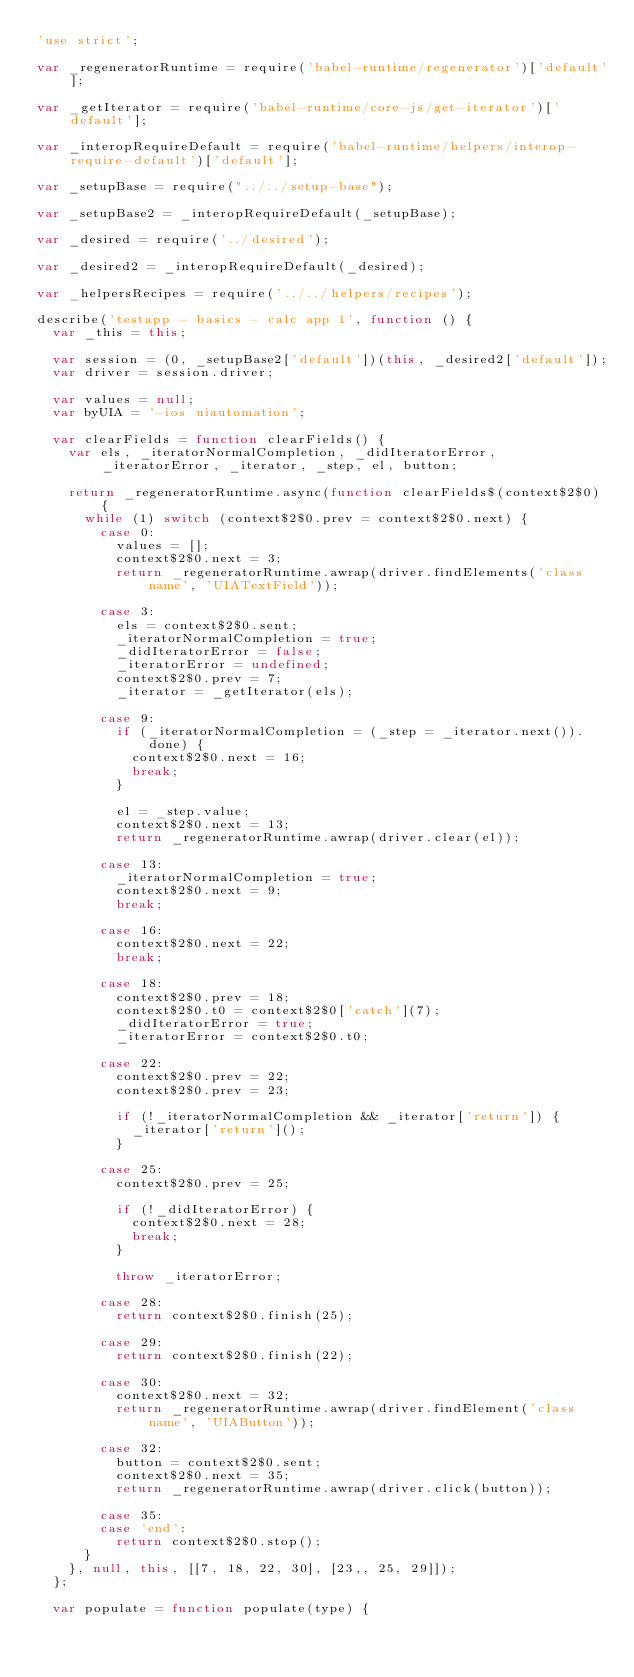Convert code to text. <code><loc_0><loc_0><loc_500><loc_500><_JavaScript_>'use strict';

var _regeneratorRuntime = require('babel-runtime/regenerator')['default'];

var _getIterator = require('babel-runtime/core-js/get-iterator')['default'];

var _interopRequireDefault = require('babel-runtime/helpers/interop-require-default')['default'];

var _setupBase = require("../../setup-base");

var _setupBase2 = _interopRequireDefault(_setupBase);

var _desired = require('../desired');

var _desired2 = _interopRequireDefault(_desired);

var _helpersRecipes = require('../../helpers/recipes');

describe('testapp - basics - calc app 1', function () {
  var _this = this;

  var session = (0, _setupBase2['default'])(this, _desired2['default']);
  var driver = session.driver;

  var values = null;
  var byUIA = '-ios uiautomation';

  var clearFields = function clearFields() {
    var els, _iteratorNormalCompletion, _didIteratorError, _iteratorError, _iterator, _step, el, button;

    return _regeneratorRuntime.async(function clearFields$(context$2$0) {
      while (1) switch (context$2$0.prev = context$2$0.next) {
        case 0:
          values = [];
          context$2$0.next = 3;
          return _regeneratorRuntime.awrap(driver.findElements('class name', 'UIATextField'));

        case 3:
          els = context$2$0.sent;
          _iteratorNormalCompletion = true;
          _didIteratorError = false;
          _iteratorError = undefined;
          context$2$0.prev = 7;
          _iterator = _getIterator(els);

        case 9:
          if (_iteratorNormalCompletion = (_step = _iterator.next()).done) {
            context$2$0.next = 16;
            break;
          }

          el = _step.value;
          context$2$0.next = 13;
          return _regeneratorRuntime.awrap(driver.clear(el));

        case 13:
          _iteratorNormalCompletion = true;
          context$2$0.next = 9;
          break;

        case 16:
          context$2$0.next = 22;
          break;

        case 18:
          context$2$0.prev = 18;
          context$2$0.t0 = context$2$0['catch'](7);
          _didIteratorError = true;
          _iteratorError = context$2$0.t0;

        case 22:
          context$2$0.prev = 22;
          context$2$0.prev = 23;

          if (!_iteratorNormalCompletion && _iterator['return']) {
            _iterator['return']();
          }

        case 25:
          context$2$0.prev = 25;

          if (!_didIteratorError) {
            context$2$0.next = 28;
            break;
          }

          throw _iteratorError;

        case 28:
          return context$2$0.finish(25);

        case 29:
          return context$2$0.finish(22);

        case 30:
          context$2$0.next = 32;
          return _regeneratorRuntime.awrap(driver.findElement('class name', 'UIAButton'));

        case 32:
          button = context$2$0.sent;
          context$2$0.next = 35;
          return _regeneratorRuntime.awrap(driver.click(button));

        case 35:
        case 'end':
          return context$2$0.stop();
      }
    }, null, this, [[7, 18, 22, 30], [23,, 25, 29]]);
  };

  var populate = function populate(type) {</code> 